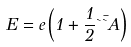Convert formula to latex. <formula><loc_0><loc_0><loc_500><loc_500>E = e \left ( 1 + \frac { 1 } { 2 } \theta \bar { \theta } A \right )</formula> 